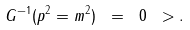Convert formula to latex. <formula><loc_0><loc_0><loc_500><loc_500>G ^ { - 1 } ( p ^ { 2 } = m ^ { 2 } ) \ = \ 0 \ > .</formula> 